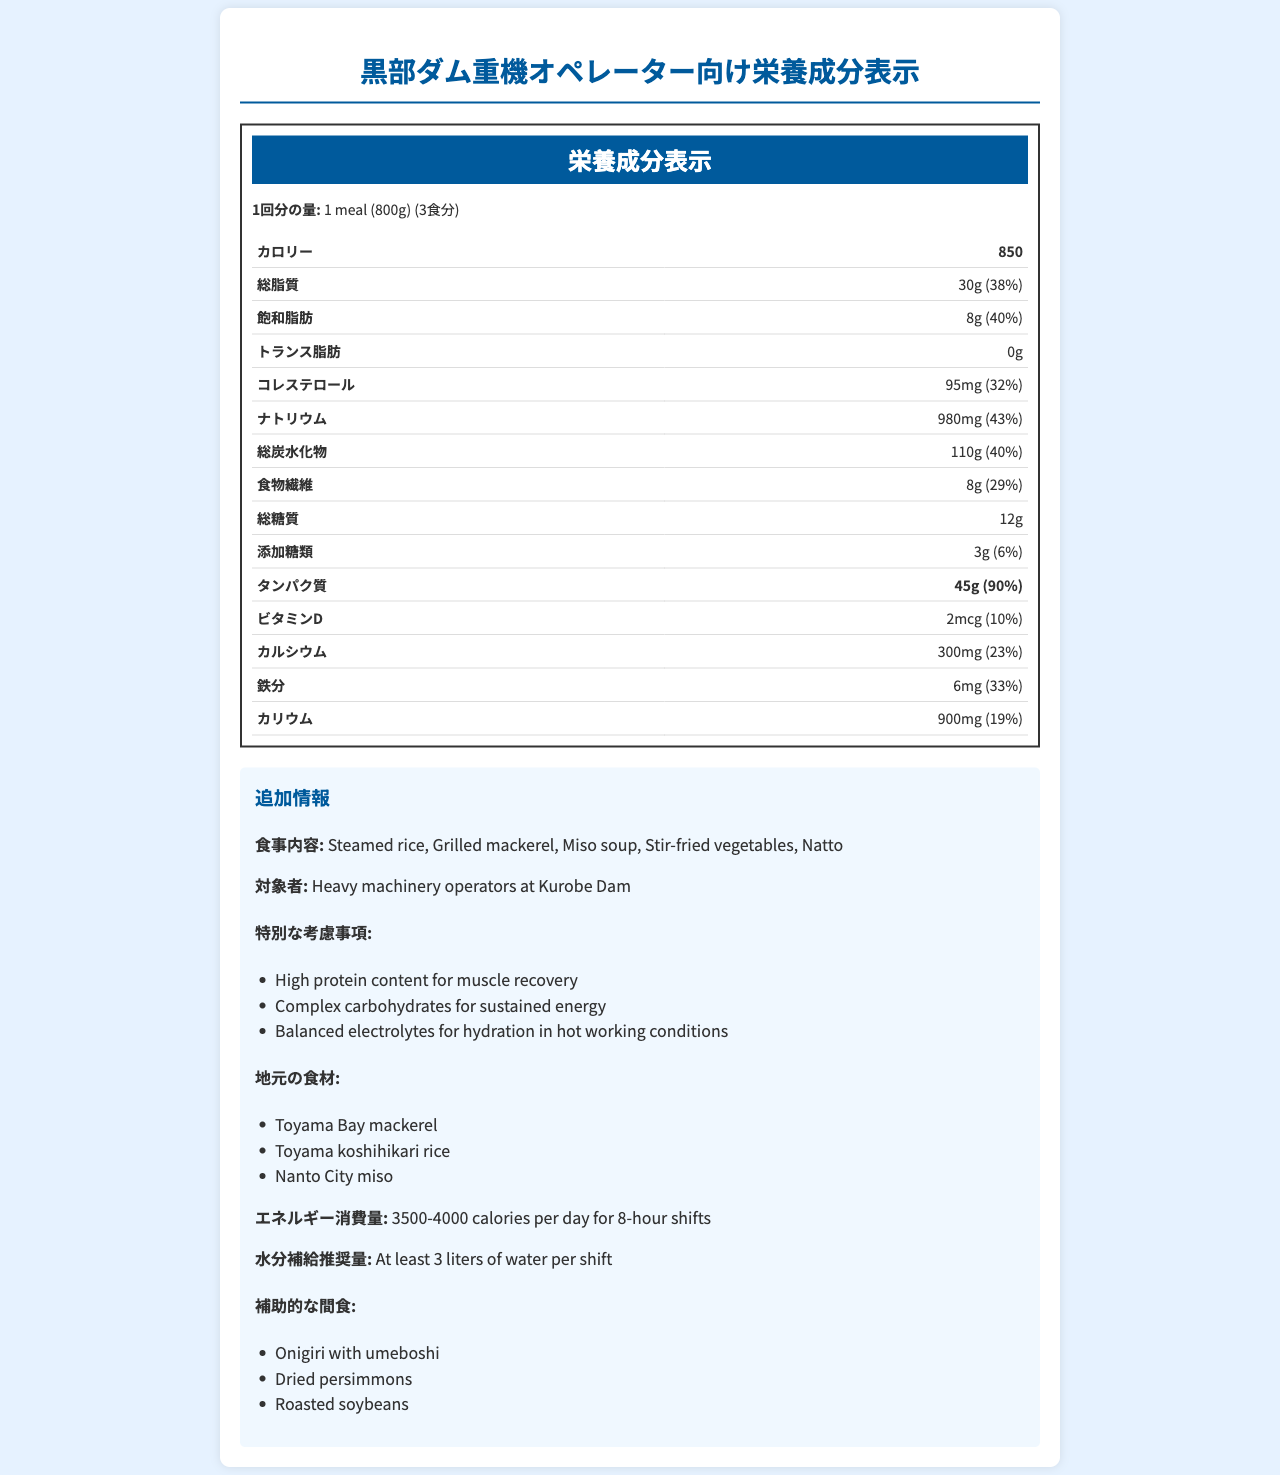how many calories are in one meal according to the nutrition facts label? The nutrition facts label specifies that one meal contains 850 calories.
Answer: 850 calories what is the protein content per meal? The document lists the protein content per meal as 45 grams, along with a daily value percentage of 90%.
Answer: 45 grams what is the serving size of one meal? The serving size of one meal is indicated as 1 meal (800g) in the document.
Answer: 1 meal (800g) how much total sugar does one meal contain? The nutrition facts indicate that one meal contains 12 grams of total sugars.
Answer: 12 grams what percentage of daily value is the total fat content per meal? According to the document, the total fat content per meal corresponds to 38% of the daily value.
Answer: 38% which of the following is NOT listed as a component of the meal? A. Grilled mackerel B. Fried chicken C. Miso soup The components listed are steamed rice, grilled mackerel, miso soup, stir-fried vegetables, and natto. Fried chicken is not listed.
Answer: B what is the main purpose of the high protein content in the meal? A. Weight gain B. Muscle recovery C. Improved digestion D. Better sleep The document specifies that the high protein content is aimed at muscle recovery.
Answer: B is there any trans fat in one meal? The document clearly indicates that there is 0 grams of trans fat in one meal.
Answer: No describe the main idea of the document The document effectively offers comprehensive nutritional details and context for the meal, emphasizing the need for balanced nutrition tailored to the physical demands of heavy machinery operators.
Answer: The document provides a detailed nutritional breakdown of a meal designed for heavy machinery operators at Kurobe Dam. It includes information on serving sizes, calorie counts, macronutrients, and micronutrients, specific target audience needs, meal components, and special considerations such as high protein content for muscle recovery and balanced electrolytes for hydration. Local ingredients used in the meal are also highlighted. how much calcium does one meal provide, and what is its percentage of the daily value? The document states that each meal provides 300 mg of calcium, which corresponds to 23% of the daily value.
Answer: 300 mg, 23% what can be deduced about the hydration recommendation for heavy machinery operators? The additional information section specifies that the hydration recommendation is to consume at least 3 liters of water per shift.
Answer: At least 3 liters of water per shift what is the energy expenditure range specified for heavy machinery operators per 8-hour shift? The document notes that the energy expenditure for heavy machinery operators is between 3500-4000 calories per day for 8-hour shifts.
Answer: 3500-4000 calories what local ingredient is used in miso soup according to the document? The document mentions that Nanto City miso is used as a local ingredient in miso soup.
Answer: Nanto City miso how many servings are in one container of this meal? The document states that there are 3 servings per container.
Answer: 3 servings what are some of the supplementary snacks suggested for operators? The supplementary snacks listed include onigiri with umeboshi, dried persimmons, and roasted soybeans.
Answer: Onigiri with umeboshi, dried persimmons, roasted soybeans what is the percentage of daily value for added sugars in one meal? The document shows that the added sugars amount to 6% of the daily value.
Answer: 6% is the exact amount of fiber in grams provided for this meal? The document specifies that the dietary fiber content in one meal is 8 grams.
Answer: Yes what is the total amount of vitamin D in one meal? The nutrition facts label indicates that one meal contains 2 micrograms of vitamin D.
Answer: 2 mcg what are the nutritional considerations for the meal designed for hot working conditions? The additional information section highlights that the meal contains balanced electrolytes for hydration, which is essential for hot working conditions.
Answer: Balanced electrolytes for hydration what is the carbohydrate content per meal, and what percentage of the daily value does it represent? The document states that each meal contains 110 grams of carbohydrates, which is 40% of the daily value.
Answer: 110 grams, 40% which city provides the rice used in the meal? The document specifies that Toyama koshihikari rice is used as one of the local ingredients in the meal.
Answer: Toyama does the document provide information about the exact temperatures operators work in? The document does not specify the exact temperatures that operators work in; it only provides recommendations for hydration in hot working conditions.
Answer: Not enough information 